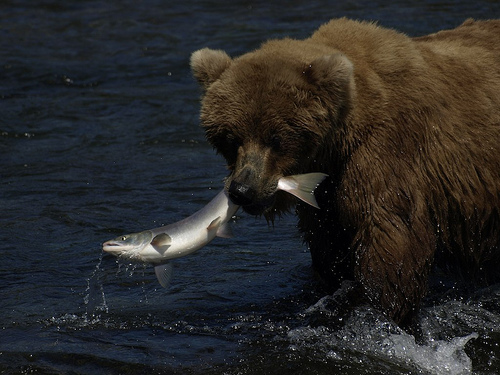How many bears are shown? There is one bear in the image, captured at the remarkable moment it's catching a fish from the water. 